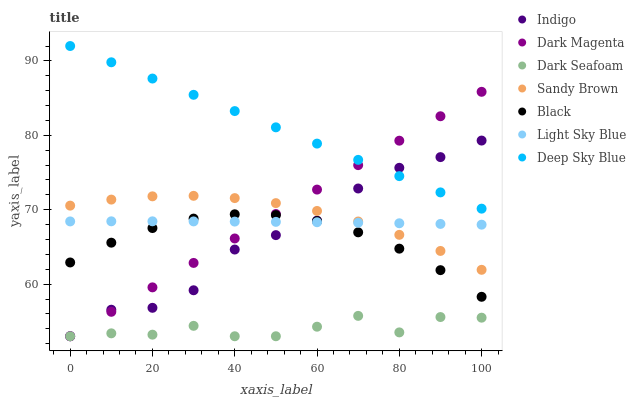Does Dark Seafoam have the minimum area under the curve?
Answer yes or no. Yes. Does Deep Sky Blue have the maximum area under the curve?
Answer yes or no. Yes. Does Dark Magenta have the minimum area under the curve?
Answer yes or no. No. Does Dark Magenta have the maximum area under the curve?
Answer yes or no. No. Is Deep Sky Blue the smoothest?
Answer yes or no. Yes. Is Indigo the roughest?
Answer yes or no. Yes. Is Dark Magenta the smoothest?
Answer yes or no. No. Is Dark Magenta the roughest?
Answer yes or no. No. Does Indigo have the lowest value?
Answer yes or no. Yes. Does Light Sky Blue have the lowest value?
Answer yes or no. No. Does Deep Sky Blue have the highest value?
Answer yes or no. Yes. Does Dark Magenta have the highest value?
Answer yes or no. No. Is Black less than Sandy Brown?
Answer yes or no. Yes. Is Light Sky Blue greater than Dark Seafoam?
Answer yes or no. Yes. Does Indigo intersect Dark Seafoam?
Answer yes or no. Yes. Is Indigo less than Dark Seafoam?
Answer yes or no. No. Is Indigo greater than Dark Seafoam?
Answer yes or no. No. Does Black intersect Sandy Brown?
Answer yes or no. No. 